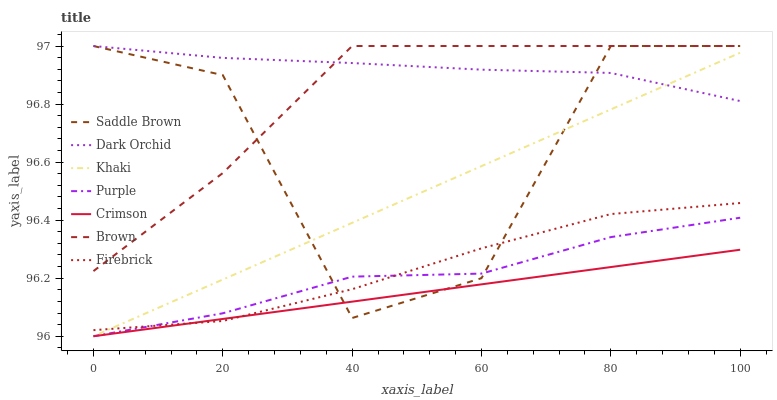Does Crimson have the minimum area under the curve?
Answer yes or no. Yes. Does Dark Orchid have the maximum area under the curve?
Answer yes or no. Yes. Does Khaki have the minimum area under the curve?
Answer yes or no. No. Does Khaki have the maximum area under the curve?
Answer yes or no. No. Is Khaki the smoothest?
Answer yes or no. Yes. Is Saddle Brown the roughest?
Answer yes or no. Yes. Is Purple the smoothest?
Answer yes or no. No. Is Purple the roughest?
Answer yes or no. No. Does Khaki have the lowest value?
Answer yes or no. Yes. Does Firebrick have the lowest value?
Answer yes or no. No. Does Saddle Brown have the highest value?
Answer yes or no. Yes. Does Khaki have the highest value?
Answer yes or no. No. Is Firebrick less than Dark Orchid?
Answer yes or no. Yes. Is Brown greater than Khaki?
Answer yes or no. Yes. Does Firebrick intersect Purple?
Answer yes or no. Yes. Is Firebrick less than Purple?
Answer yes or no. No. Is Firebrick greater than Purple?
Answer yes or no. No. Does Firebrick intersect Dark Orchid?
Answer yes or no. No. 